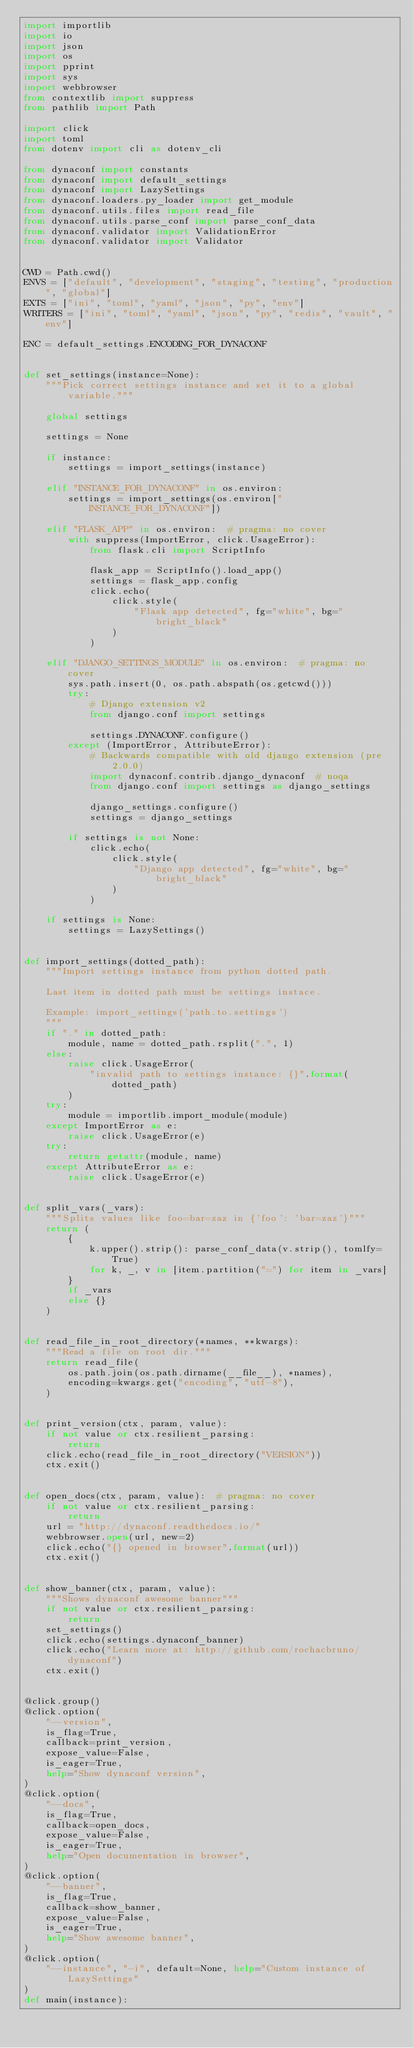<code> <loc_0><loc_0><loc_500><loc_500><_Python_>import importlib
import io
import json
import os
import pprint
import sys
import webbrowser
from contextlib import suppress
from pathlib import Path

import click
import toml
from dotenv import cli as dotenv_cli

from dynaconf import constants
from dynaconf import default_settings
from dynaconf import LazySettings
from dynaconf.loaders.py_loader import get_module
from dynaconf.utils.files import read_file
from dynaconf.utils.parse_conf import parse_conf_data
from dynaconf.validator import ValidationError
from dynaconf.validator import Validator


CWD = Path.cwd()
ENVS = ["default", "development", "staging", "testing", "production", "global"]
EXTS = ["ini", "toml", "yaml", "json", "py", "env"]
WRITERS = ["ini", "toml", "yaml", "json", "py", "redis", "vault", "env"]

ENC = default_settings.ENCODING_FOR_DYNACONF


def set_settings(instance=None):
    """Pick correct settings instance and set it to a global variable."""

    global settings

    settings = None

    if instance:
        settings = import_settings(instance)

    elif "INSTANCE_FOR_DYNACONF" in os.environ:
        settings = import_settings(os.environ["INSTANCE_FOR_DYNACONF"])

    elif "FLASK_APP" in os.environ:  # pragma: no cover
        with suppress(ImportError, click.UsageError):
            from flask.cli import ScriptInfo

            flask_app = ScriptInfo().load_app()
            settings = flask_app.config
            click.echo(
                click.style(
                    "Flask app detected", fg="white", bg="bright_black"
                )
            )

    elif "DJANGO_SETTINGS_MODULE" in os.environ:  # pragma: no cover
        sys.path.insert(0, os.path.abspath(os.getcwd()))
        try:
            # Django extension v2
            from django.conf import settings

            settings.DYNACONF.configure()
        except (ImportError, AttributeError):
            # Backwards compatible with old django extension (pre 2.0.0)
            import dynaconf.contrib.django_dynaconf  # noqa
            from django.conf import settings as django_settings

            django_settings.configure()
            settings = django_settings

        if settings is not None:
            click.echo(
                click.style(
                    "Django app detected", fg="white", bg="bright_black"
                )
            )

    if settings is None:
        settings = LazySettings()


def import_settings(dotted_path):
    """Import settings instance from python dotted path.

    Last item in dotted path must be settings instace.

    Example: import_settings('path.to.settings')
    """
    if "." in dotted_path:
        module, name = dotted_path.rsplit(".", 1)
    else:
        raise click.UsageError(
            "invalid path to settings instance: {}".format(dotted_path)
        )
    try:
        module = importlib.import_module(module)
    except ImportError as e:
        raise click.UsageError(e)
    try:
        return getattr(module, name)
    except AttributeError as e:
        raise click.UsageError(e)


def split_vars(_vars):
    """Splits values like foo=bar=zaz in {'foo': 'bar=zaz'}"""
    return (
        {
            k.upper().strip(): parse_conf_data(v.strip(), tomlfy=True)
            for k, _, v in [item.partition("=") for item in _vars]
        }
        if _vars
        else {}
    )


def read_file_in_root_directory(*names, **kwargs):
    """Read a file on root dir."""
    return read_file(
        os.path.join(os.path.dirname(__file__), *names),
        encoding=kwargs.get("encoding", "utf-8"),
    )


def print_version(ctx, param, value):
    if not value or ctx.resilient_parsing:
        return
    click.echo(read_file_in_root_directory("VERSION"))
    ctx.exit()


def open_docs(ctx, param, value):  # pragma: no cover
    if not value or ctx.resilient_parsing:
        return
    url = "http://dynaconf.readthedocs.io/"
    webbrowser.open(url, new=2)
    click.echo("{} opened in browser".format(url))
    ctx.exit()


def show_banner(ctx, param, value):
    """Shows dynaconf awesome banner"""
    if not value or ctx.resilient_parsing:
        return
    set_settings()
    click.echo(settings.dynaconf_banner)
    click.echo("Learn more at: http://github.com/rochacbruno/dynaconf")
    ctx.exit()


@click.group()
@click.option(
    "--version",
    is_flag=True,
    callback=print_version,
    expose_value=False,
    is_eager=True,
    help="Show dynaconf version",
)
@click.option(
    "--docs",
    is_flag=True,
    callback=open_docs,
    expose_value=False,
    is_eager=True,
    help="Open documentation in browser",
)
@click.option(
    "--banner",
    is_flag=True,
    callback=show_banner,
    expose_value=False,
    is_eager=True,
    help="Show awesome banner",
)
@click.option(
    "--instance", "-i", default=None, help="Custom instance of LazySettings"
)
def main(instance):</code> 